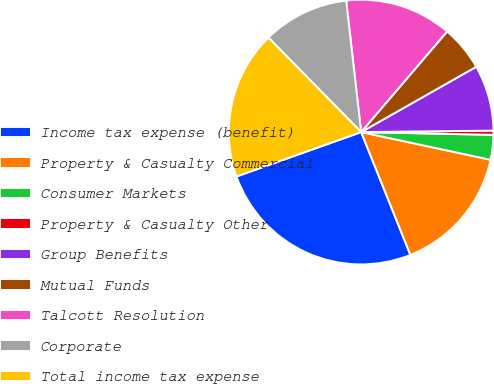<chart> <loc_0><loc_0><loc_500><loc_500><pie_chart><fcel>Income tax expense (benefit)<fcel>Property & Casualty Commercial<fcel>Consumer Markets<fcel>Property & Casualty Other<fcel>Group Benefits<fcel>Mutual Funds<fcel>Talcott Resolution<fcel>Corporate<fcel>Total income tax expense<nl><fcel>25.62%<fcel>15.57%<fcel>3.02%<fcel>0.51%<fcel>8.04%<fcel>5.53%<fcel>13.06%<fcel>10.55%<fcel>18.09%<nl></chart> 